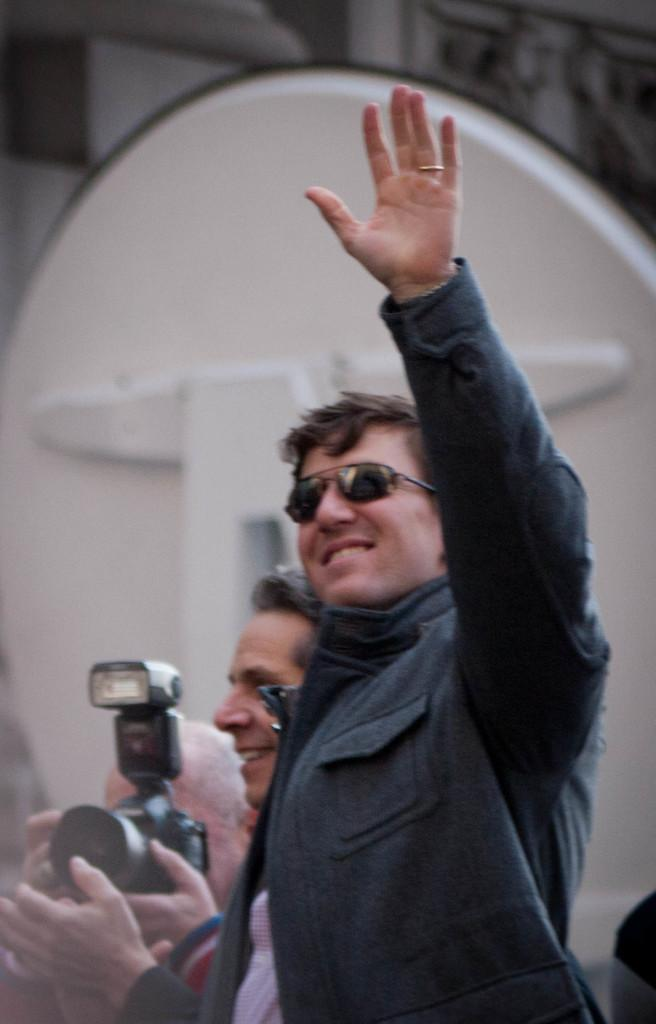What is the main subject of the image? The main subject of the image is a group of people in the middle. What is one person in the group doing? A man is waving his hand. Can you describe the background of the image? In the background, there is a man holding a camera. What type of cork can be seen floating in the water in the image? There is no water or cork present in the image; it features a group of people and a man holding a camera in the background. 